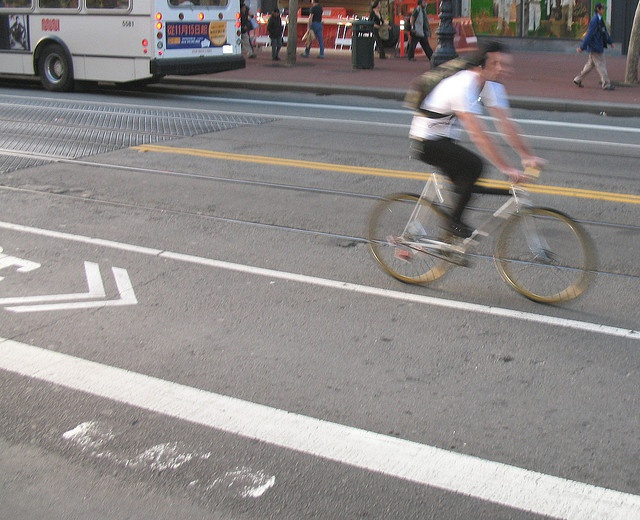Describe the objects in this image and their specific colors. I can see bicycle in black and gray tones, bus in black, darkgray, and gray tones, people in black, darkgray, gray, and lavender tones, backpack in black, gray, and darkgray tones, and people in black, gray, and navy tones in this image. 